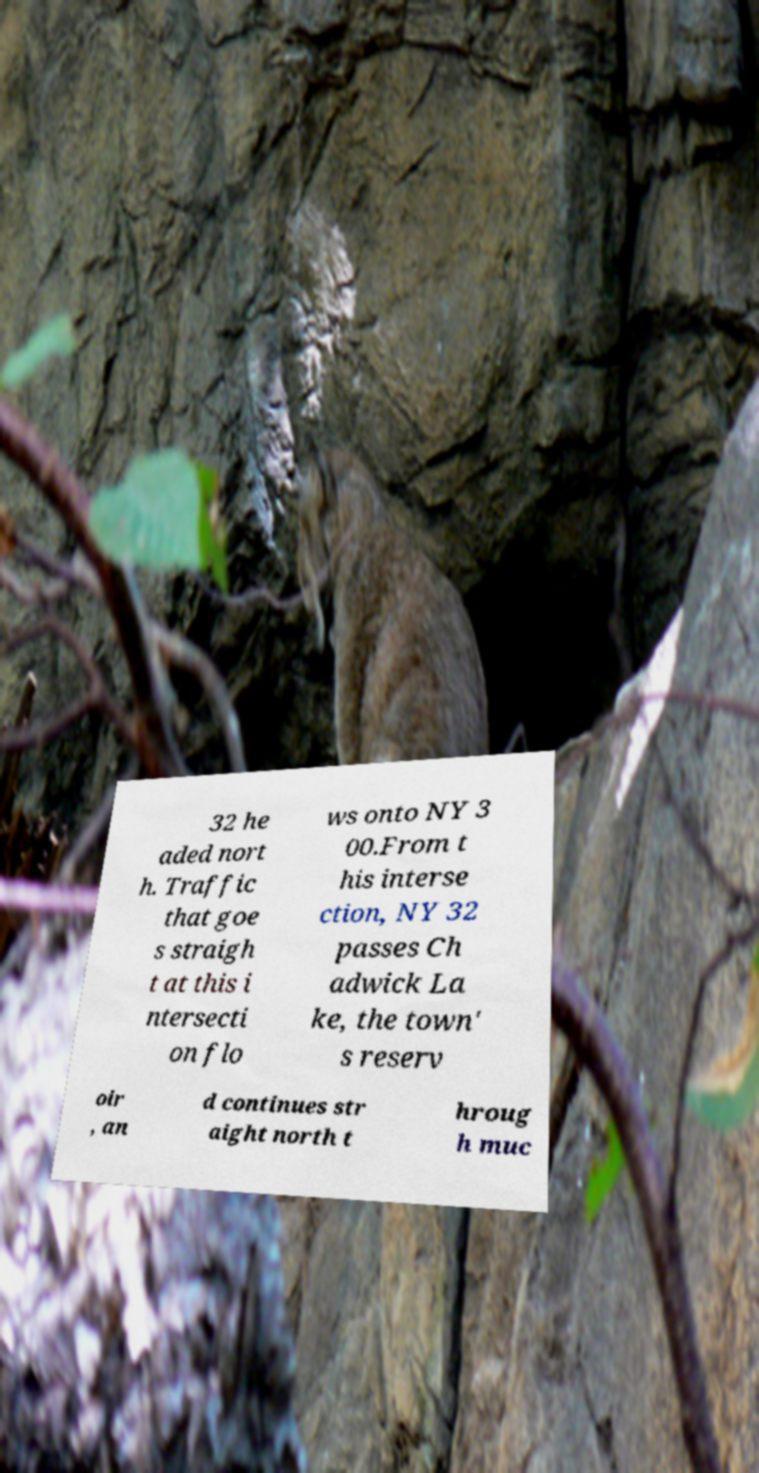For documentation purposes, I need the text within this image transcribed. Could you provide that? 32 he aded nort h. Traffic that goe s straigh t at this i ntersecti on flo ws onto NY 3 00.From t his interse ction, NY 32 passes Ch adwick La ke, the town' s reserv oir , an d continues str aight north t hroug h muc 